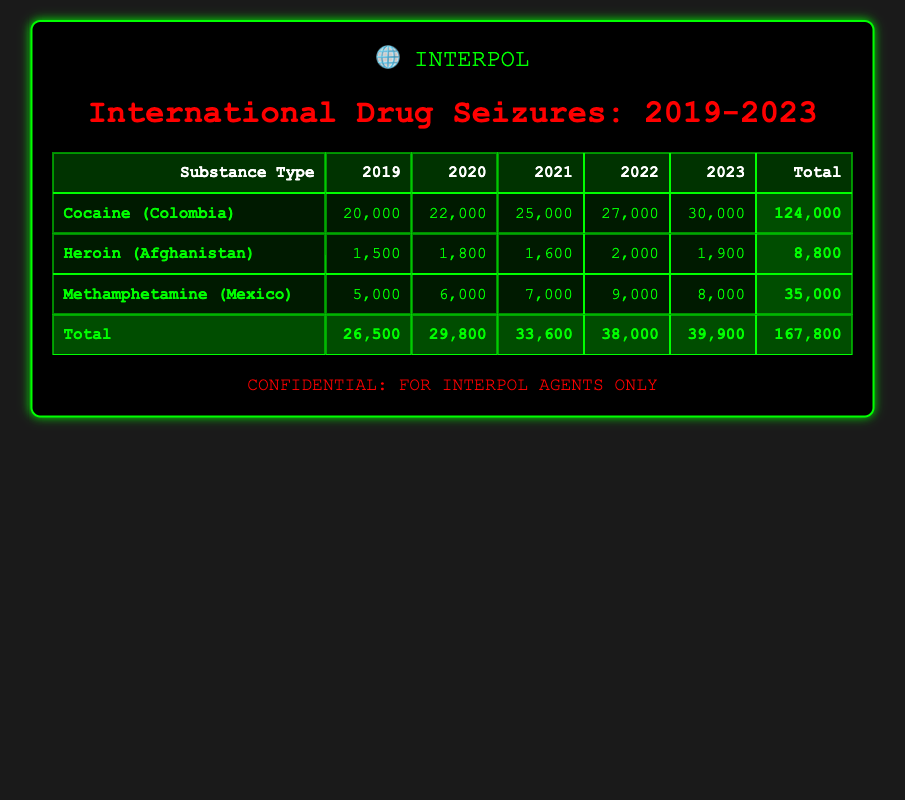What was the total quantity of cocaine seized in 2020? In 2020, the table shows that 22,000 units of cocaine were seized. This information is directly available in the corresponding cell for cocaine under the year 2020.
Answer: 22,000 Which substance type had the highest quantity seized in 2021? In 2021, cocaine had the highest quantity seized at 25,000 compared to heroin (1,600) and methamphetamine (7,000). Therefore, cocaine was the one with the highest amount.
Answer: Cocaine What is the total quantity of methamphetamine seized over the five years? By looking at the quantities for methamphetamine each year, we see 5,000 (2019) + 6,000 (2020) + 7,000 (2021) + 9,000 (2022) + 8,000 (2023) = 35,000 as the total. Therefore, we add these quantities together to find the total.
Answer: 35,000 Did the quantity of heroin seized decrease from 2022 to 2023? In 2022, 2,000 units of heroin were seized, and in 2023, 1,900 units were seized. Since 1,900 is less than 2,000, this indicates a decrease, confirming the answer is yes.
Answer: Yes What is the average quantity of cocaine seized over the years from 2019 to 2023? The total quantity of cocaine over these years is 20,000 (2019) + 22,000 (2020) + 25,000 (2021) + 27,000 (2022) + 30,000 (2023) = 124,000. There are 5 years in total, so the average is 124,000 / 5 = 24,800.
Answer: 24,800 What is the increase in the quantity of cocaine seized from 2020 to 2021? The quantity of cocaine seized in 2020 was 22,000 and in 2021 it was 25,000. The increase is found by taking 25,000 - 22,000 = 3,000. Thus, the increase from 2020 to 2021 is 3,000.
Answer: 3,000 In which year was the lowest total of heroin seized recorded? By reviewing the data for heroin, we see that in 2019, 1,500 units were seized, which is lower than 1,800 (2020), 1,600 (2021), 2,000 (2022), and 1,900 (2023). Hence, 2019 recorded the lowest quantity.
Answer: 2019 Was more cocaine seized than methamphetamine in 2022? In 2022, cocaine totaled 27,000 and methamphetamine totaled 9,000. Since 27,000 is greater than 9,000, it confirms that more cocaine was seized than methamphetamine.
Answer: Yes 